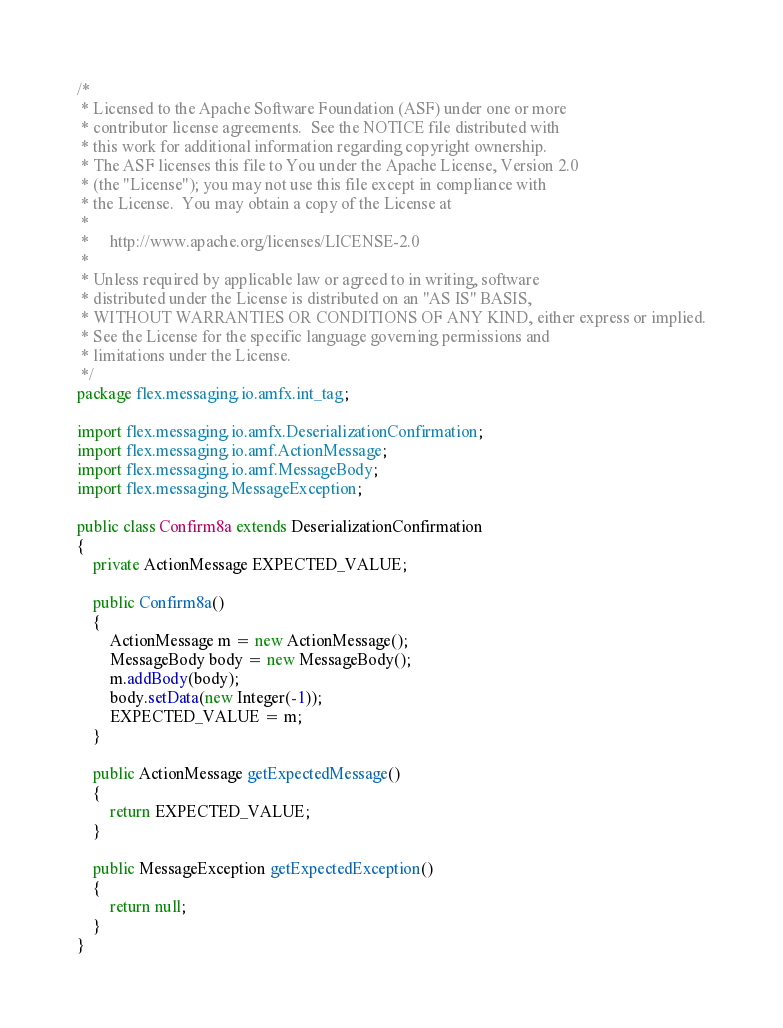<code> <loc_0><loc_0><loc_500><loc_500><_Java_>/*
 * Licensed to the Apache Software Foundation (ASF) under one or more
 * contributor license agreements.  See the NOTICE file distributed with
 * this work for additional information regarding copyright ownership.
 * The ASF licenses this file to You under the Apache License, Version 2.0
 * (the "License"); you may not use this file except in compliance with
 * the License.  You may obtain a copy of the License at
 *
 *     http://www.apache.org/licenses/LICENSE-2.0
 *
 * Unless required by applicable law or agreed to in writing, software
 * distributed under the License is distributed on an "AS IS" BASIS,
 * WITHOUT WARRANTIES OR CONDITIONS OF ANY KIND, either express or implied.
 * See the License for the specific language governing permissions and
 * limitations under the License.
 */
package flex.messaging.io.amfx.int_tag;

import flex.messaging.io.amfx.DeserializationConfirmation;
import flex.messaging.io.amf.ActionMessage;
import flex.messaging.io.amf.MessageBody;
import flex.messaging.MessageException;

public class Confirm8a extends DeserializationConfirmation
{
    private ActionMessage EXPECTED_VALUE;

    public Confirm8a()
    {
        ActionMessage m = new ActionMessage();
        MessageBody body = new MessageBody();
        m.addBody(body);
        body.setData(new Integer(-1));
        EXPECTED_VALUE = m;
    }

    public ActionMessage getExpectedMessage()
    {
        return EXPECTED_VALUE;
    }

    public MessageException getExpectedException()
    {
        return null;
    }
}
</code> 